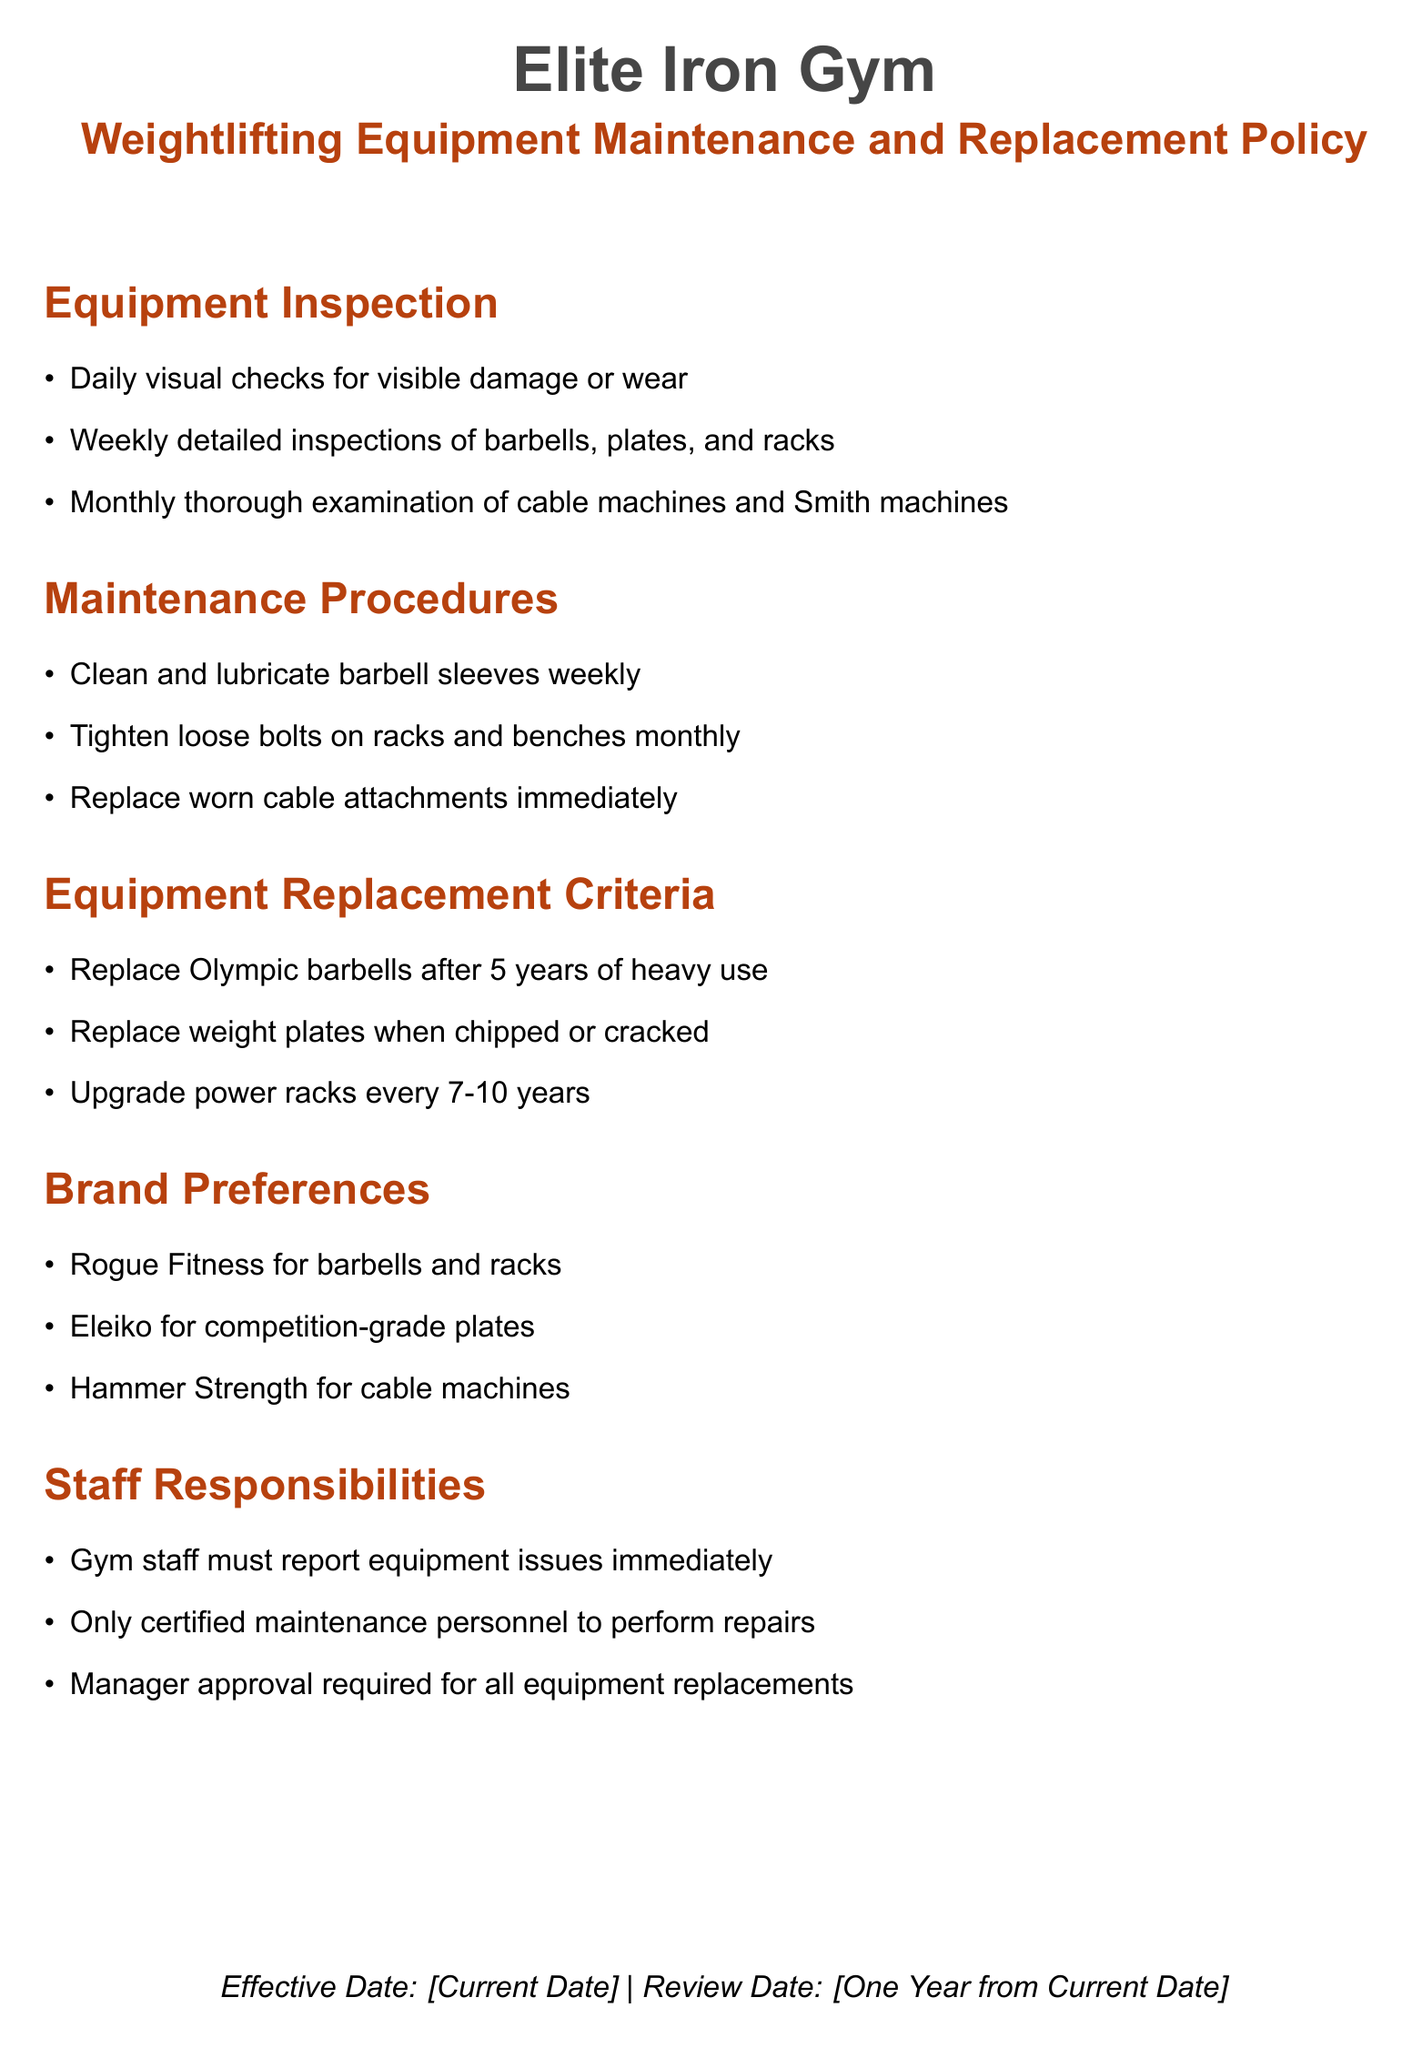What is the effective date of the policy? The effective date is mentioned at the bottom of the document, represented as the current date.
Answer: [Current Date] How often should barbells be cleaned and lubricated? The maintenance procedures specify that barbell sleeves should be cleaned and lubricated weekly.
Answer: weekly What is the replacement cycle for Olympic barbells? The document states that Olympic barbells should be replaced after 5 years of heavy use.
Answer: 5 years Which brand is preferred for competition-grade plates? The brand preferences list Eleiko as the preferred brand for competition-grade plates.
Answer: Eleiko What inspections should be performed monthly? Monthly thorough examinations are specified for cable machines and Smith machines.
Answer: cable machines and Smith machines What is required for all equipment replacements? The document states that manager approval is required for all equipment replacements.
Answer: manager approval How quickly should worn cable attachments be replaced? The maintenance procedures indicate that worn cable attachments should be replaced immediately.
Answer: immediately How frequently should loose bolts on racks and benches be tightened? The maintenance procedures recommend tightening loose bolts on racks and benches monthly.
Answer: monthly What is the maximum age for upgrading power racks? The equipment replacement criteria mentions that power racks should be upgraded every 7-10 years.
Answer: 7-10 years 